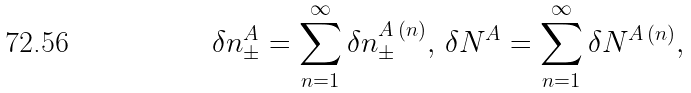Convert formula to latex. <formula><loc_0><loc_0><loc_500><loc_500>\delta n ^ { A } _ { \pm } = \sum _ { n = 1 } ^ { \infty } \delta n ^ { A \, ( n ) } _ { \pm } , \, \delta N ^ { A } = \sum _ { n = 1 } ^ { \infty } \delta N ^ { A \, ( n ) } ,</formula> 